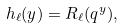<formula> <loc_0><loc_0><loc_500><loc_500>h _ { \ell } ( y ) = R _ { \ell } ( q ^ { y } ) ,</formula> 